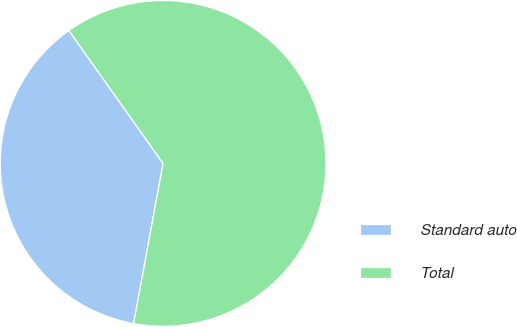Convert chart. <chart><loc_0><loc_0><loc_500><loc_500><pie_chart><fcel>Standard auto<fcel>Total<nl><fcel>37.29%<fcel>62.71%<nl></chart> 